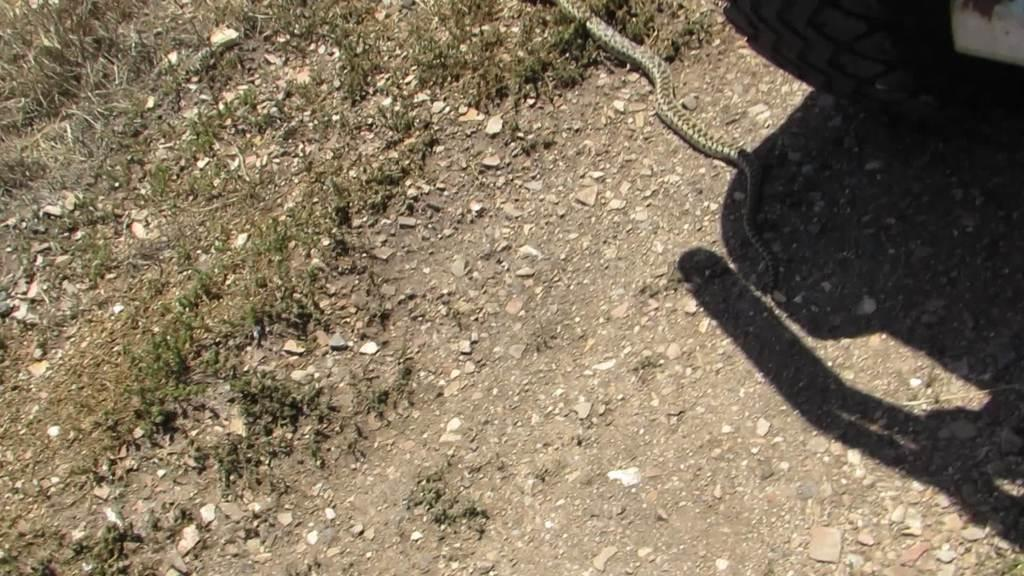What type of animal is in the image? There is a snake in the image. What other object is present in the image? There is a tire in the image. Where are the snake and the tire located? Both the snake and the tire are on the ground. What type of weather can be seen in the image? There is no information about the weather in the image, as it only features a snake and a tire on the ground. Is the snake wearing a cap in the image? There is no cap present in the image, as it only features a snake and a tire on the ground. 